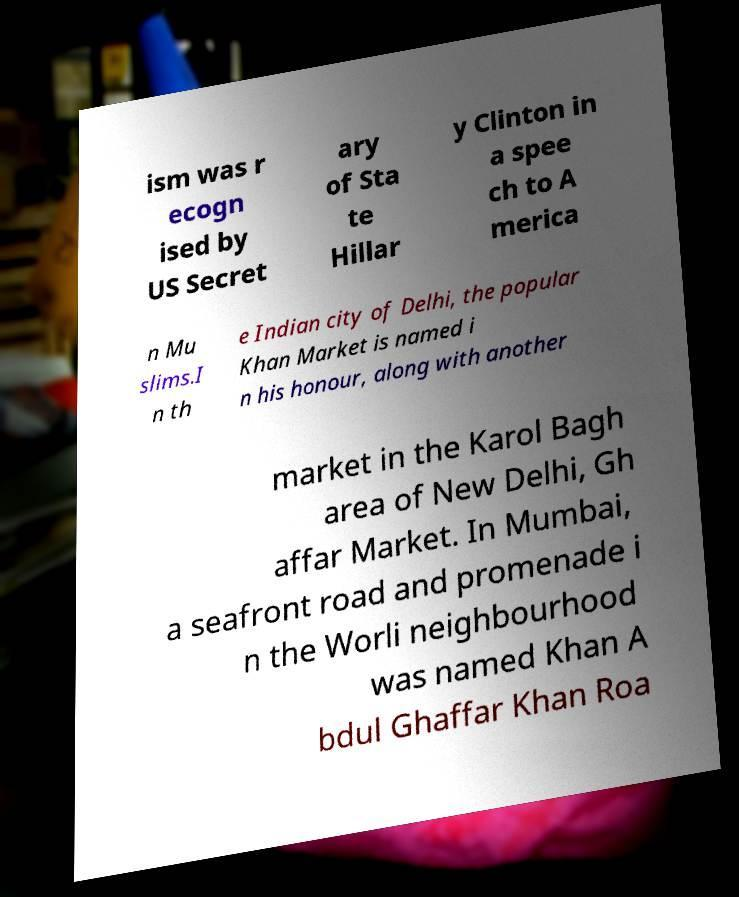For documentation purposes, I need the text within this image transcribed. Could you provide that? ism was r ecogn ised by US Secret ary of Sta te Hillar y Clinton in a spee ch to A merica n Mu slims.I n th e Indian city of Delhi, the popular Khan Market is named i n his honour, along with another market in the Karol Bagh area of New Delhi, Gh affar Market. In Mumbai, a seafront road and promenade i n the Worli neighbourhood was named Khan A bdul Ghaffar Khan Roa 